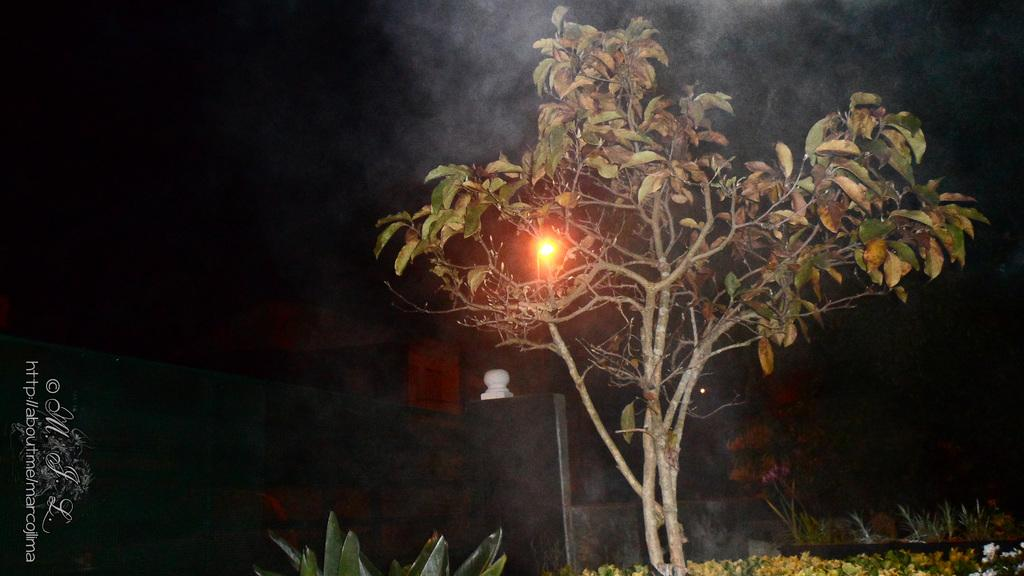What type of vegetation can be seen in the image? There is a tree and plants in the image. What can be seen illuminating the scene in the image? There is a light in the image. What is visible in the background of the image? The sky is visible in the image. How would you describe the overall lighting in the image? The image appears to be dark. Where is the coat hanging in the image? There is no coat present in the image. What type of operation is being performed in the image? There is no operation or any indication of one in the image. 